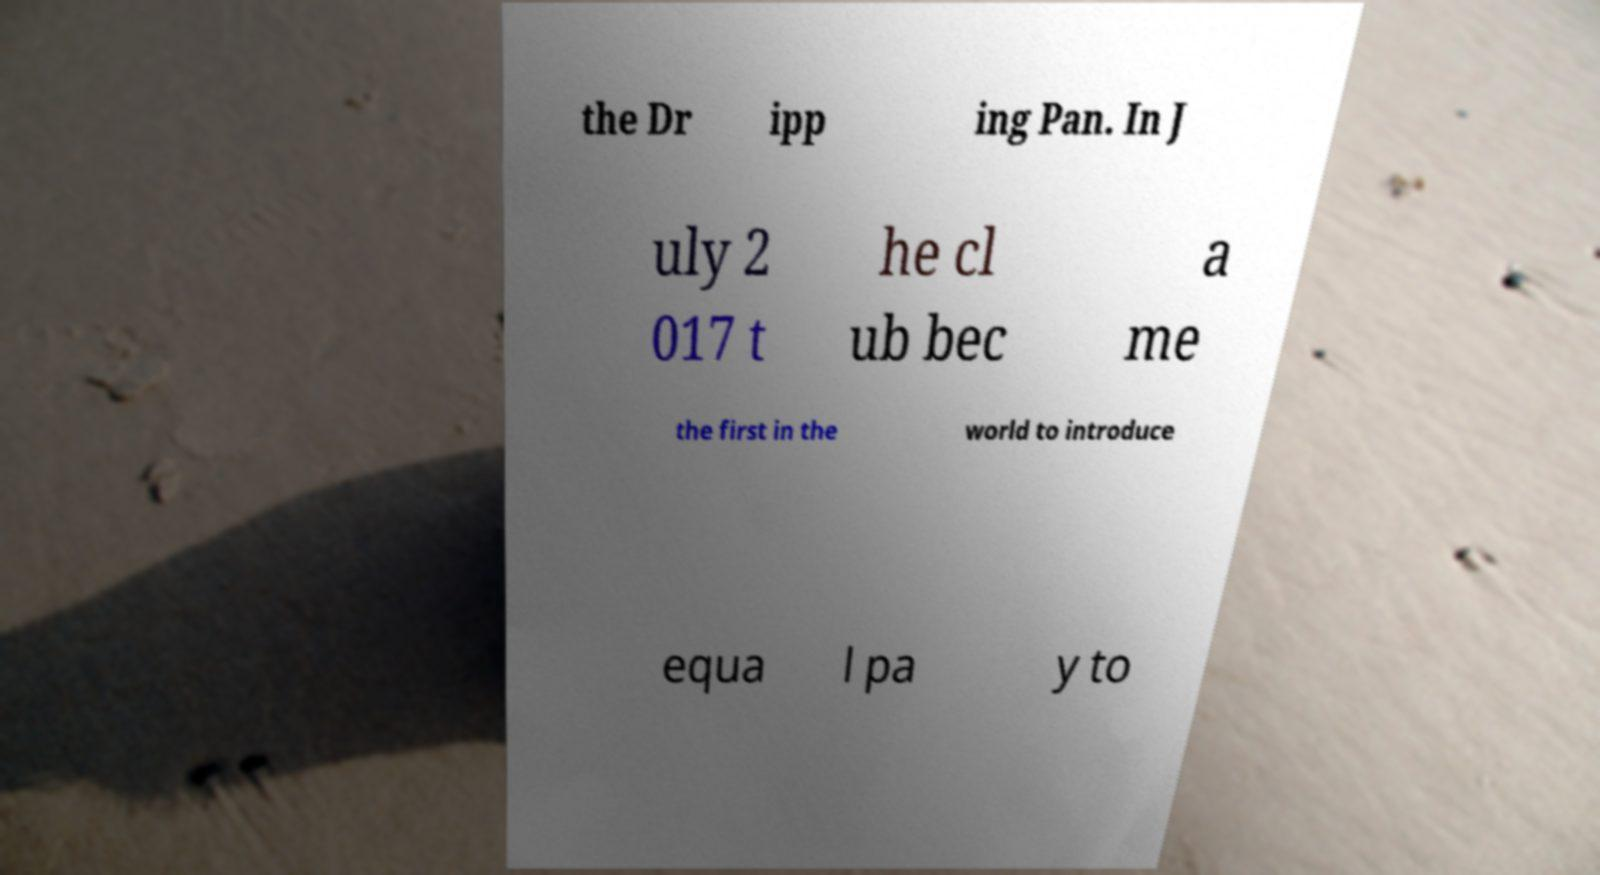For documentation purposes, I need the text within this image transcribed. Could you provide that? the Dr ipp ing Pan. In J uly 2 017 t he cl ub bec a me the first in the world to introduce equa l pa y to 